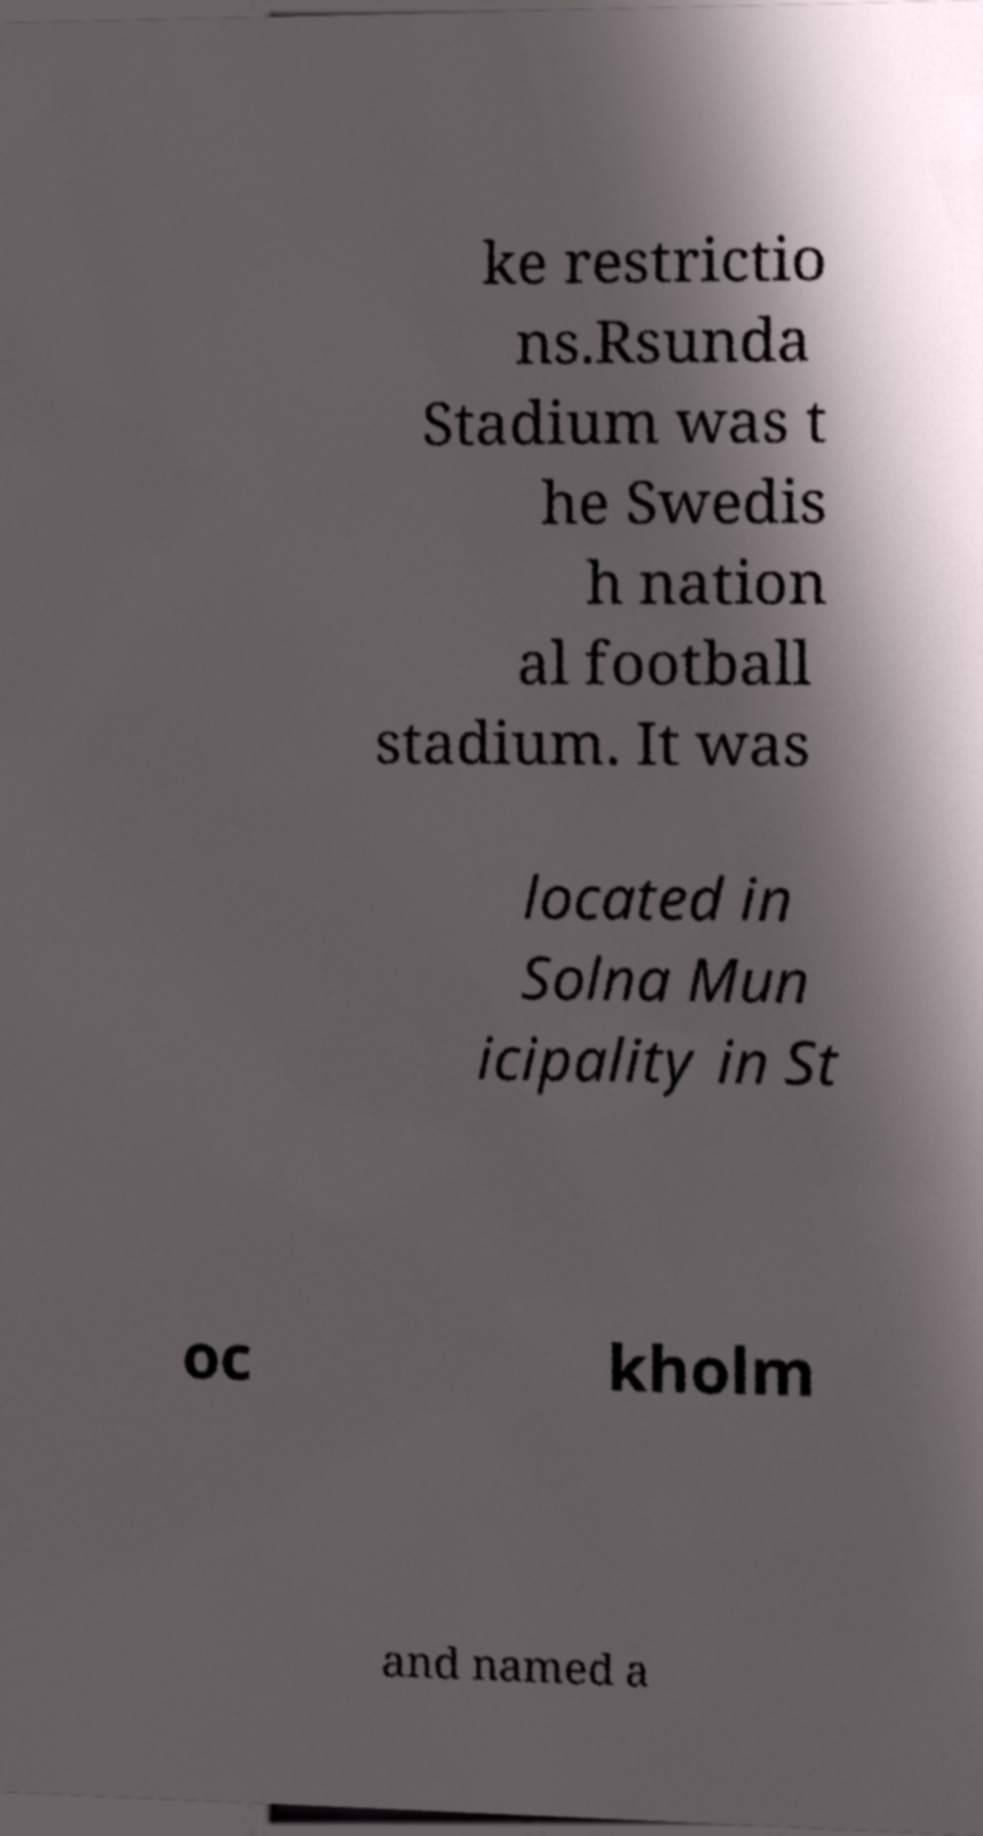Please identify and transcribe the text found in this image. ke restrictio ns.Rsunda Stadium was t he Swedis h nation al football stadium. It was located in Solna Mun icipality in St oc kholm and named a 